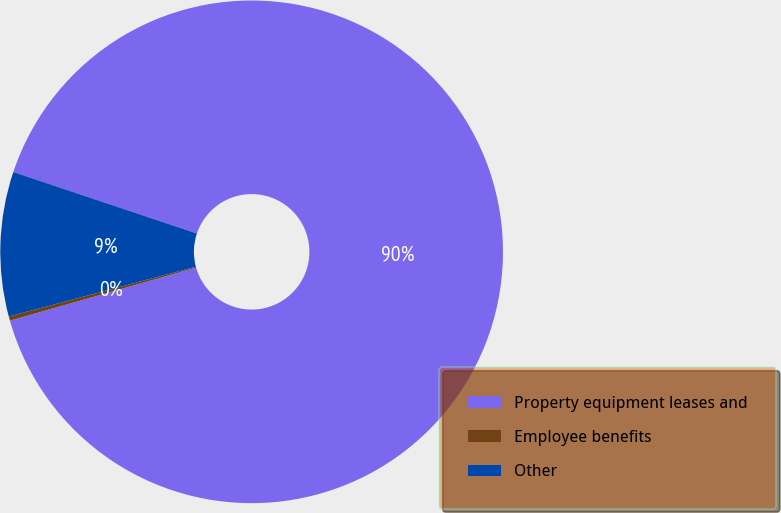<chart> <loc_0><loc_0><loc_500><loc_500><pie_chart><fcel>Property equipment leases and<fcel>Employee benefits<fcel>Other<nl><fcel>90.44%<fcel>0.27%<fcel>9.29%<nl></chart> 